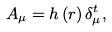<formula> <loc_0><loc_0><loc_500><loc_500>A _ { \mu } = h \left ( r \right ) \delta _ { \mu } ^ { t } ,</formula> 